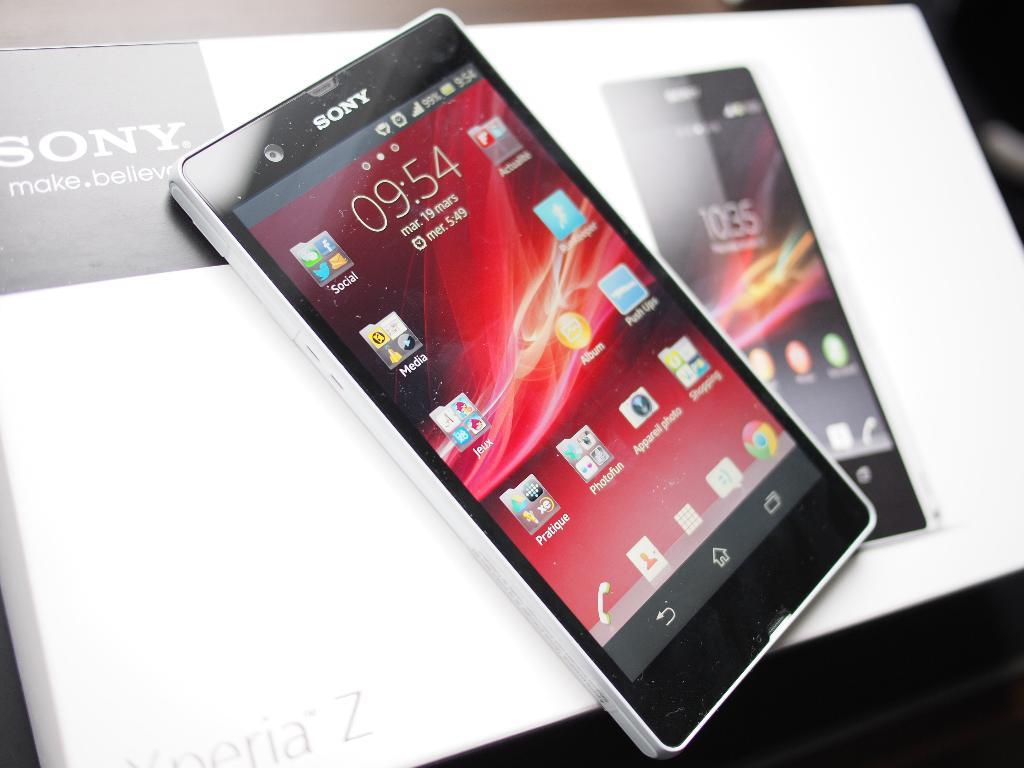<image>
Write a terse but informative summary of the picture. A smart phone which has the time displayed as 09.54 